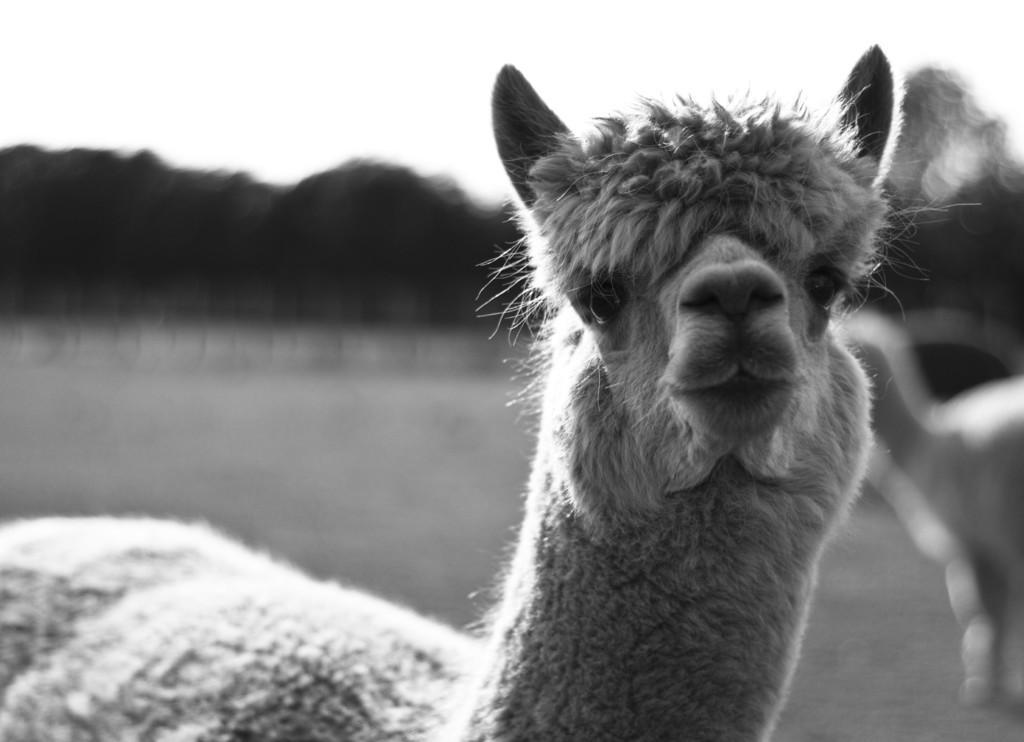Could you give a brief overview of what you see in this image? It is a black and white image. In this image we can see an animal and the background is blurred. 